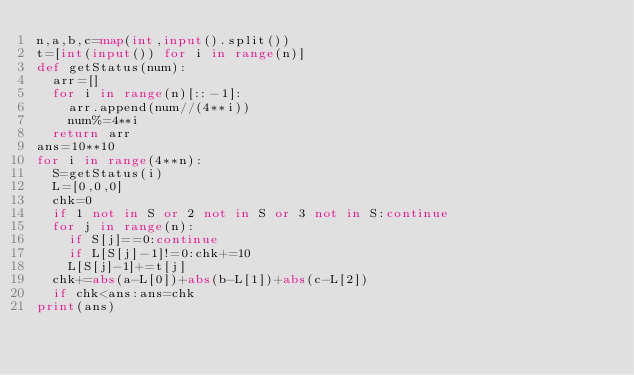<code> <loc_0><loc_0><loc_500><loc_500><_Python_>n,a,b,c=map(int,input().split())
t=[int(input()) for i in range(n)]
def getStatus(num):
  arr=[]
  for i in range(n)[::-1]:
    arr.append(num//(4**i))
    num%=4**i
  return arr
ans=10**10
for i in range(4**n):
  S=getStatus(i)
  L=[0,0,0]
  chk=0
  if 1 not in S or 2 not in S or 3 not in S:continue
  for j in range(n):
    if S[j]==0:continue
    if L[S[j]-1]!=0:chk+=10
    L[S[j]-1]+=t[j]
  chk+=abs(a-L[0])+abs(b-L[1])+abs(c-L[2])
  if chk<ans:ans=chk
print(ans)</code> 